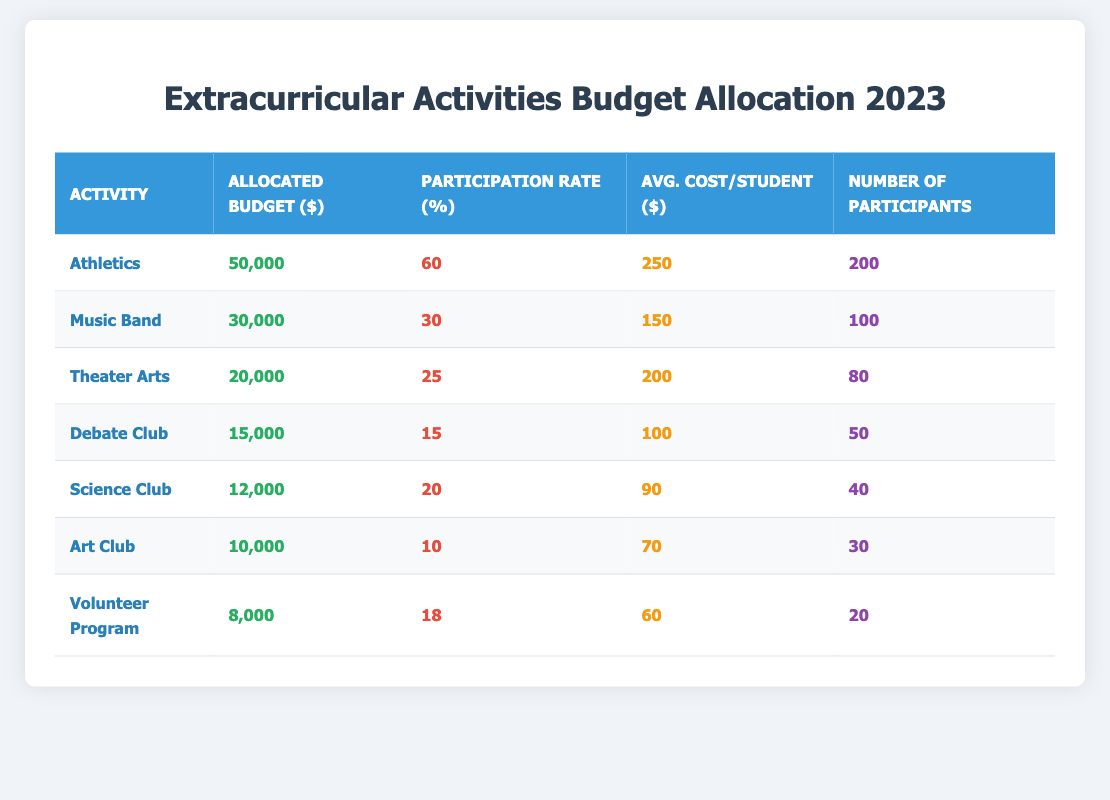What is the allocated budget for the Music Band? The table lists the allocated budget for each extracurricular activity. For the Music Band, the allocated budget is directly stated as $30,000.
Answer: 30,000 How many participants are there in the Athletics activity? The number of participants is clearly shown in the table under the "Number of Participants" column for each activity. For Athletics, the value is 200.
Answer: 200 Which activity has the highest participation rate? The participation rates for all activities are listed. By scanning the table, we see that Athletics has the highest participation rate at 60%.
Answer: Athletics What is the average cost per student for the Debate Club? The average cost per student for each activity is provided in the table. For the Debate Club, this figure is $100.
Answer: 100 Calculate the total allocated budget for all activities combined. To find the total allocated budget, we need to sum the budgets for each activity: 50,000 + 30,000 + 20,000 + 15,000 + 12,000 + 10,000 + 8,000 = 145,000.
Answer: 145,000 Is the average cost per student for the Science Club greater than the average cost for the Art Club? For the Science Club, the average cost per student is $90, and for the Art Club, it is $70. Since $90 > $70, the answer is yes.
Answer: Yes What is the total number of participants across all extracurricular activities? To find the total number of participants, we sum the number of participants for all activities: 200 + 100 + 80 + 50 + 40 + 30 + 20 = 620.
Answer: 620 If the allocated budget for the Volunteer Program were increased by 50%, what would the new budget be? The current allocated budget for the Volunteer Program is $8,000. An increase of 50% means we calculate: 8,000 + (50/100 * 8,000) = 8,000 + 4,000 = 12,000.
Answer: 12,000 Which activity has the lowest participation rate and what is that rate? Looking at the participation rates in the table, we see that the Art Club has the lowest participation rate at 10%.
Answer: Art Club, 10% If you were to prioritize funding based on participation and cost, which activity would be most efficient (highest participation per budget dollar)? To find efficiency, we divide the number of participants by the allocated budget for each activity. Calculating yields: Athletics (200/50,000 = 0.004), Music Band (100/30,000 = 0.0033), Theater Arts (80/20,000 = 0.004), etc. The highest efficiency is with Athletics at 0.004.
Answer: Athletics 